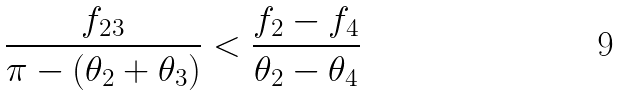<formula> <loc_0><loc_0><loc_500><loc_500>\frac { f _ { 2 3 } } { \pi - ( \theta _ { 2 } + \theta _ { 3 } ) } < \frac { f _ { 2 } - f _ { 4 } } { \theta _ { 2 } - \theta _ { 4 } }</formula> 